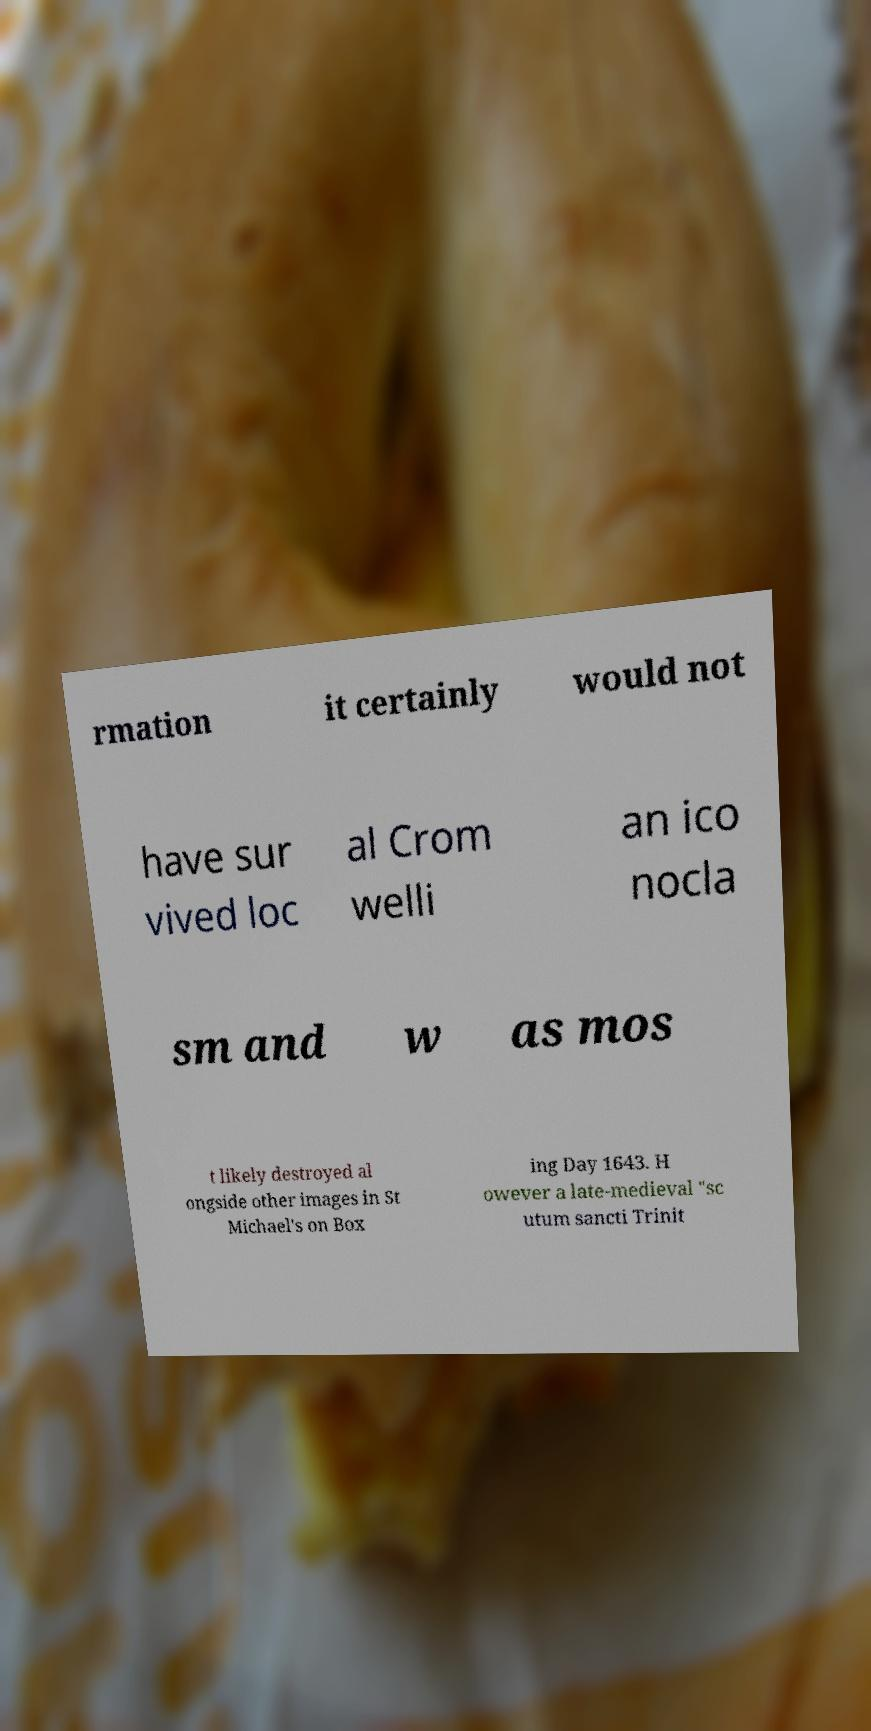Can you read and provide the text displayed in the image?This photo seems to have some interesting text. Can you extract and type it out for me? rmation it certainly would not have sur vived loc al Crom welli an ico nocla sm and w as mos t likely destroyed al ongside other images in St Michael's on Box ing Day 1643. H owever a late-medieval "sc utum sancti Trinit 